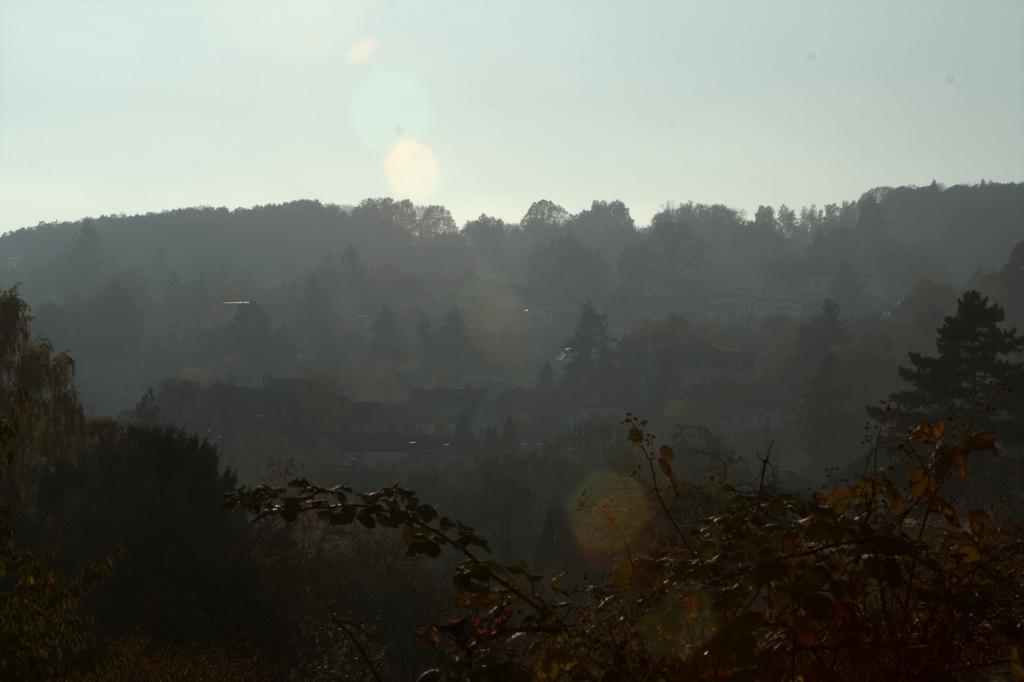What type of natural landform can be seen in the image? There are mountains in the image. What type of vegetation is present in the image? There are trees in the image. What type of man-made structures can be seen in the background of the image? There are buildings in the background of the image. What is visible at the top of the image? The sky is visible at the top of the image. What can be seen in the sky in the image? Clouds are present in the sky. Where is the notebook located in the image? There is no notebook present in the image. What type of experience can be gained from the ants in the image? There are no ants present in the image, so no experience can be gained from them. 